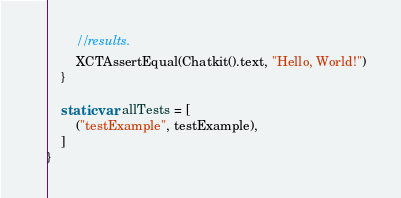Convert code to text. <code><loc_0><loc_0><loc_500><loc_500><_Swift_>        // results.
        XCTAssertEqual(Chatkit().text, "Hello, World!")
    }

    static var allTests = [
        ("testExample", testExample),
    ]
}
</code> 